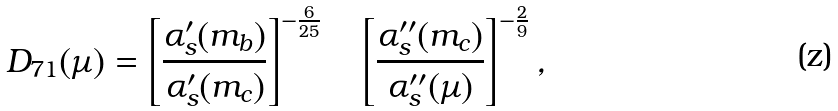<formula> <loc_0><loc_0><loc_500><loc_500>D _ { 7 1 } ( \mu ) = \left [ \frac { \alpha _ { s } ^ { \prime } ( m _ { b } ) } { \alpha _ { s } ^ { \prime } ( m _ { c } ) } \right ] ^ { - \frac { 6 } { 2 5 } } \quad \left [ \frac { \alpha _ { s } ^ { \prime \prime } ( m _ { c } ) } { \alpha _ { s } ^ { \prime \prime } ( \mu ) } \right ] ^ { - \frac { 2 } { 9 } } ,</formula> 